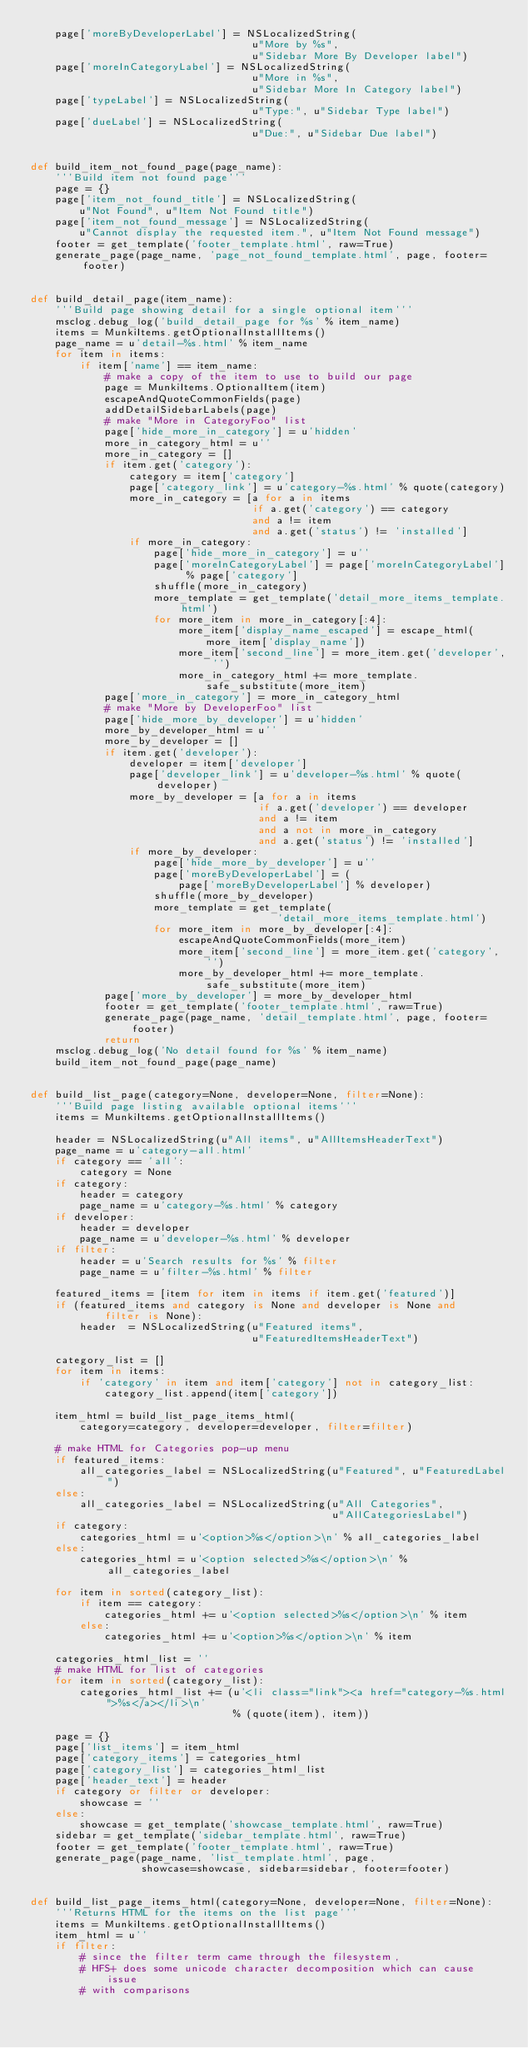Convert code to text. <code><loc_0><loc_0><loc_500><loc_500><_Python_>    page['moreByDeveloperLabel'] = NSLocalizedString(
                                    u"More by %s",
                                    u"Sidebar More By Developer label")
    page['moreInCategoryLabel'] = NSLocalizedString(
                                    u"More in %s",
                                    u"Sidebar More In Category label")
    page['typeLabel'] = NSLocalizedString(
                                    u"Type:", u"Sidebar Type label")
    page['dueLabel'] = NSLocalizedString(
                                    u"Due:", u"Sidebar Due label")


def build_item_not_found_page(page_name):
    '''Build item not found page'''
    page = {}
    page['item_not_found_title'] = NSLocalizedString(
        u"Not Found", u"Item Not Found title")
    page['item_not_found_message'] = NSLocalizedString(
        u"Cannot display the requested item.", u"Item Not Found message")
    footer = get_template('footer_template.html', raw=True)
    generate_page(page_name, 'page_not_found_template.html', page, footer=footer)


def build_detail_page(item_name):
    '''Build page showing detail for a single optional item'''
    msclog.debug_log('build_detail_page for %s' % item_name)
    items = MunkiItems.getOptionalInstallItems()
    page_name = u'detail-%s.html' % item_name
    for item in items:
        if item['name'] == item_name:
            # make a copy of the item to use to build our page
            page = MunkiItems.OptionalItem(item)
            escapeAndQuoteCommonFields(page)
            addDetailSidebarLabels(page)
            # make "More in CategoryFoo" list
            page['hide_more_in_category'] = u'hidden'
            more_in_category_html = u''
            more_in_category = []
            if item.get('category'):
                category = item['category']
                page['category_link'] = u'category-%s.html' % quote(category)
                more_in_category = [a for a in items
                                    if a.get('category') == category
                                    and a != item
                                    and a.get('status') != 'installed']
                if more_in_category:
                    page['hide_more_in_category'] = u''
                    page['moreInCategoryLabel'] = page['moreInCategoryLabel'] % page['category']
                    shuffle(more_in_category)
                    more_template = get_template('detail_more_items_template.html')
                    for more_item in more_in_category[:4]:
                        more_item['display_name_escaped'] = escape_html(more_item['display_name'])
                        more_item['second_line'] = more_item.get('developer', '')
                        more_in_category_html += more_template.safe_substitute(more_item)
            page['more_in_category'] = more_in_category_html
            # make "More by DeveloperFoo" list
            page['hide_more_by_developer'] = u'hidden'
            more_by_developer_html = u''
            more_by_developer = []
            if item.get('developer'):
                developer = item['developer']
                page['developer_link'] = u'developer-%s.html' % quote(developer)
                more_by_developer = [a for a in items
                                     if a.get('developer') == developer
                                     and a != item
                                     and a not in more_in_category
                                     and a.get('status') != 'installed']
                if more_by_developer:
                    page['hide_more_by_developer'] = u''
                    page['moreByDeveloperLabel'] = (
                        page['moreByDeveloperLabel'] % developer)
                    shuffle(more_by_developer)
                    more_template = get_template(
                                        'detail_more_items_template.html')
                    for more_item in more_by_developer[:4]:
                        escapeAndQuoteCommonFields(more_item)
                        more_item['second_line'] = more_item.get('category', '')
                        more_by_developer_html += more_template.safe_substitute(more_item)
            page['more_by_developer'] = more_by_developer_html
            footer = get_template('footer_template.html', raw=True)
            generate_page(page_name, 'detail_template.html', page, footer=footer)
            return
    msclog.debug_log('No detail found for %s' % item_name)
    build_item_not_found_page(page_name)


def build_list_page(category=None, developer=None, filter=None):
    '''Build page listing available optional items'''
    items = MunkiItems.getOptionalInstallItems()

    header = NSLocalizedString(u"All items", u"AllItemsHeaderText")
    page_name = u'category-all.html'
    if category == 'all':
        category = None
    if category:
        header = category
        page_name = u'category-%s.html' % category
    if developer:
        header = developer
        page_name = u'developer-%s.html' % developer
    if filter:
        header = u'Search results for %s' % filter
        page_name = u'filter-%s.html' % filter

    featured_items = [item for item in items if item.get('featured')]
    if (featured_items and category is None and developer is None and
            filter is None):
        header  = NSLocalizedString(u"Featured items",
                                    u"FeaturedItemsHeaderText")

    category_list = []
    for item in items:
        if 'category' in item and item['category'] not in category_list:
            category_list.append(item['category'])

    item_html = build_list_page_items_html(
        category=category, developer=developer, filter=filter)

    # make HTML for Categories pop-up menu
    if featured_items:
        all_categories_label = NSLocalizedString(u"Featured", u"FeaturedLabel")
    else:
        all_categories_label = NSLocalizedString(u"All Categories",
                                                 u"AllCategoriesLabel")
    if category:
        categories_html = u'<option>%s</option>\n' % all_categories_label
    else:
        categories_html = u'<option selected>%s</option>\n' % all_categories_label

    for item in sorted(category_list):
        if item == category:
            categories_html += u'<option selected>%s</option>\n' % item
        else:
            categories_html += u'<option>%s</option>\n' % item

    categories_html_list = ''
    # make HTML for list of categories
    for item in sorted(category_list):
        categories_html_list += (u'<li class="link"><a href="category-%s.html">%s</a></li>\n'
                                 % (quote(item), item))

    page = {}
    page['list_items'] = item_html
    page['category_items'] = categories_html
    page['category_list'] = categories_html_list
    page['header_text'] = header
    if category or filter or developer:
        showcase = ''
    else:
        showcase = get_template('showcase_template.html', raw=True)
    sidebar = get_template('sidebar_template.html', raw=True)
    footer = get_template('footer_template.html', raw=True)
    generate_page(page_name, 'list_template.html', page,
                  showcase=showcase, sidebar=sidebar, footer=footer)


def build_list_page_items_html(category=None, developer=None, filter=None):
    '''Returns HTML for the items on the list page'''
    items = MunkiItems.getOptionalInstallItems()
    item_html = u''
    if filter:
        # since the filter term came through the filesystem,
        # HFS+ does some unicode character decomposition which can cause issue
        # with comparisons</code> 